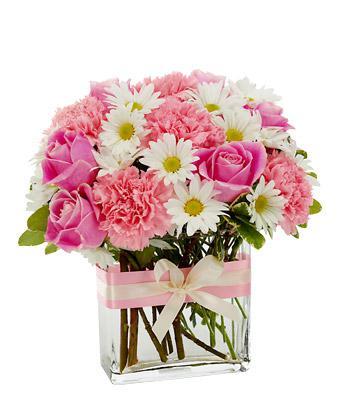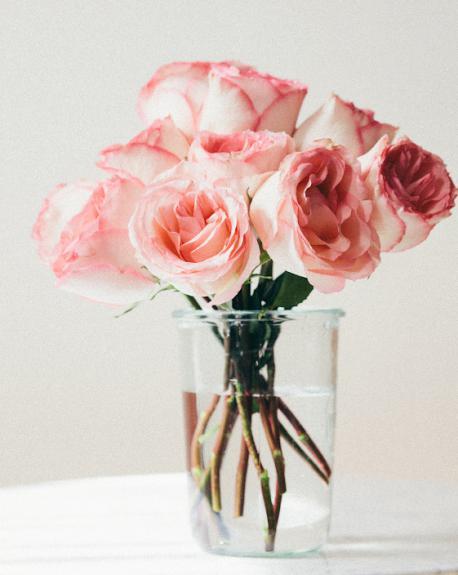The first image is the image on the left, the second image is the image on the right. Examine the images to the left and right. Is the description "Every container is either white or clear" accurate? Answer yes or no. Yes. The first image is the image on the left, the second image is the image on the right. Analyze the images presented: Is the assertion "Some of the vases are see-thru; you can see the stems through the vase walls." valid? Answer yes or no. Yes. 